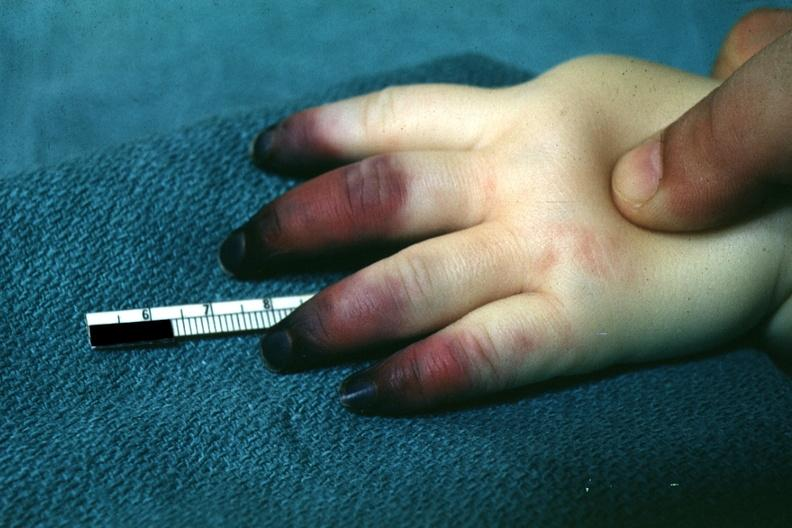re extremities present?
Answer the question using a single word or phrase. Yes 